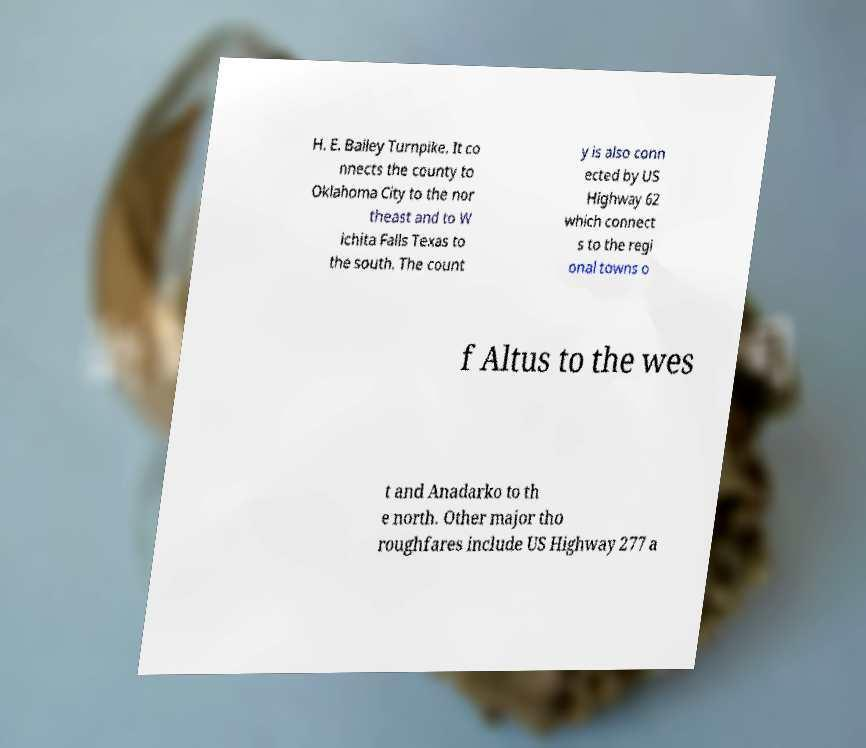Please identify and transcribe the text found in this image. H. E. Bailey Turnpike. It co nnects the county to Oklahoma City to the nor theast and to W ichita Falls Texas to the south. The count y is also conn ected by US Highway 62 which connect s to the regi onal towns o f Altus to the wes t and Anadarko to th e north. Other major tho roughfares include US Highway 277 a 